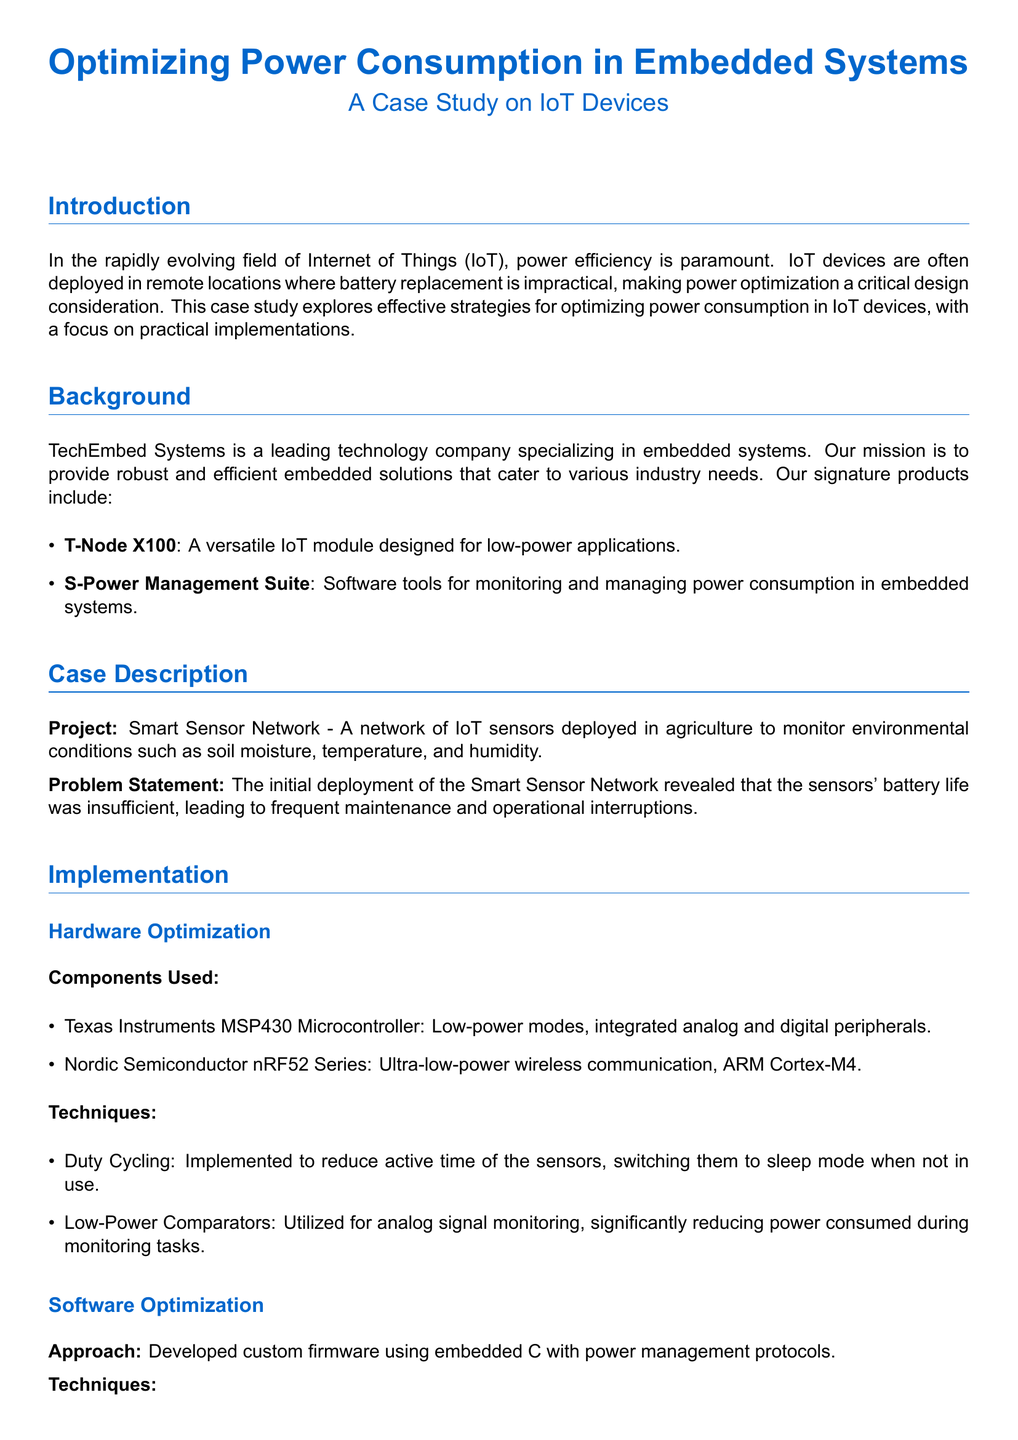What is the main focus of this case study? The main focus of the case study is on optimizing power consumption in IoT devices.
Answer: Optimizing power consumption in IoT devices What is the name of the company conducting the case study? The company conducting the case study is named TechEmbed Systems.
Answer: TechEmbed Systems What microcontroller was used for hardware optimization? The microcontroller used is the Texas Instruments MSP430.
Answer: Texas Instruments MSP430 What technique was implemented to reduce the sensors' active time? The technique implemented to reduce active time is duty cycling.
Answer: Duty cycling How much power consumption was observed after optimization? The optimized power consumption was 50mAh per day.
Answer: 50mAh per day What was the initial battery life of the sensors? The initial battery life of the sensors was 3 months.
Answer: 3 months What software approach was taken for power management? The software approach taken was developing custom firmware using embedded C.
Answer: Custom firmware using embedded C Which wireless communication technology was utilized? The wireless communication technology utilized was Nordic Semiconductor nRF52 Series.
Answer: Nordic Semiconductor nRF52 Series What power management technique adjusts voltage based on processing power? The technique that adjusts voltage based on required processing power is dynamic voltage scaling.
Answer: Dynamic voltage scaling 